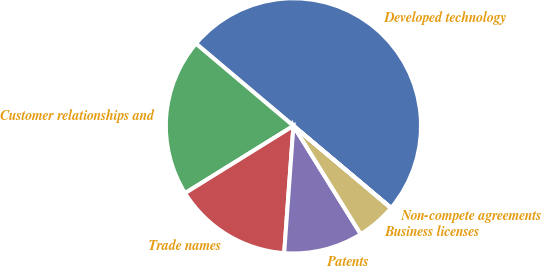<chart> <loc_0><loc_0><loc_500><loc_500><pie_chart><fcel>Developed technology<fcel>Customer relationships and<fcel>Trade names<fcel>Patents<fcel>Business licenses<fcel>Non-compete agreements<nl><fcel>49.97%<fcel>20.0%<fcel>15.0%<fcel>10.01%<fcel>5.01%<fcel>0.01%<nl></chart> 